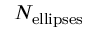Convert formula to latex. <formula><loc_0><loc_0><loc_500><loc_500>N _ { e l l i p s e s }</formula> 